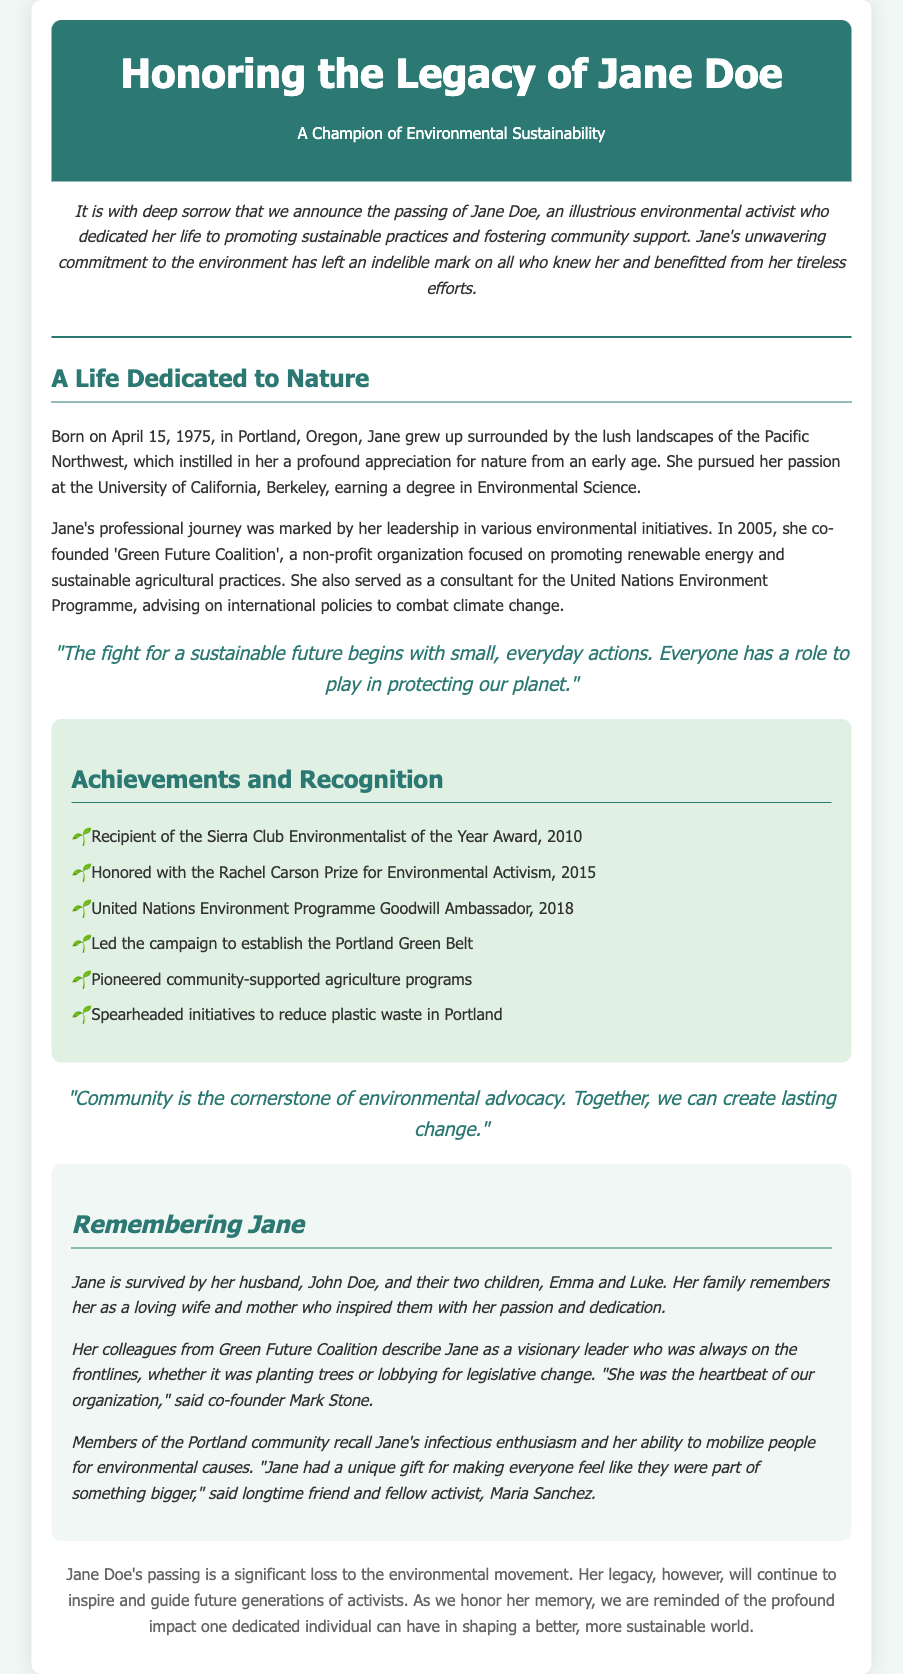What is Jane Doe's date of birth? The document states that Jane was born on April 15, 1975.
Answer: April 15, 1975 What organization did Jane co-found in 2005? The document mentions that Jane co-founded 'Green Future Coalition' in 2005.
Answer: Green Future Coalition Who described Jane as "the heartbeat of our organization"? The co-founder Mark Stone described Jane in that manner.
Answer: Mark Stone What award did Jane receive in 2010? According to the document, she received the Sierra Club Environmentalist of the Year Award in 2010.
Answer: Sierra Club Environmentalist of the Year Award What role did Jane hold with the United Nations Environment Programme in 2018? The document states that she was a Goodwill Ambassador for the United Nations Environment Programme in 2018.
Answer: Goodwill Ambassador How many children did Jane have? The document indicates that Jane had two children.
Answer: Two What did Jane believe community is the cornerstone of? The document quotes Jane stating that community is the cornerstone of environmental advocacy.
Answer: Environmental advocacy What is a significant impact of Jane's legacy mentioned in the document? The document states her legacy will continue to inspire and guide future generations of activists.
Answer: Inspire and guide future generations 